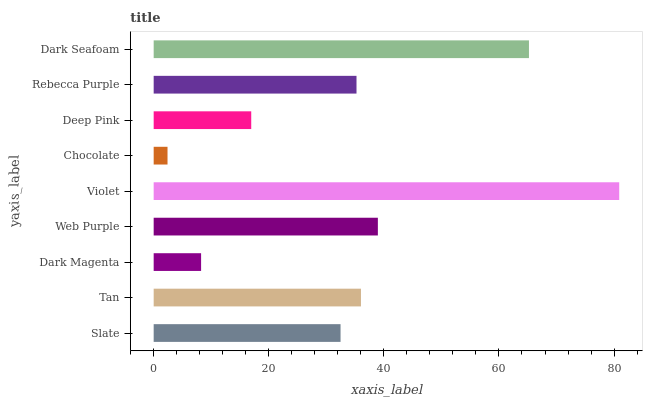Is Chocolate the minimum?
Answer yes or no. Yes. Is Violet the maximum?
Answer yes or no. Yes. Is Tan the minimum?
Answer yes or no. No. Is Tan the maximum?
Answer yes or no. No. Is Tan greater than Slate?
Answer yes or no. Yes. Is Slate less than Tan?
Answer yes or no. Yes. Is Slate greater than Tan?
Answer yes or no. No. Is Tan less than Slate?
Answer yes or no. No. Is Rebecca Purple the high median?
Answer yes or no. Yes. Is Rebecca Purple the low median?
Answer yes or no. Yes. Is Deep Pink the high median?
Answer yes or no. No. Is Slate the low median?
Answer yes or no. No. 